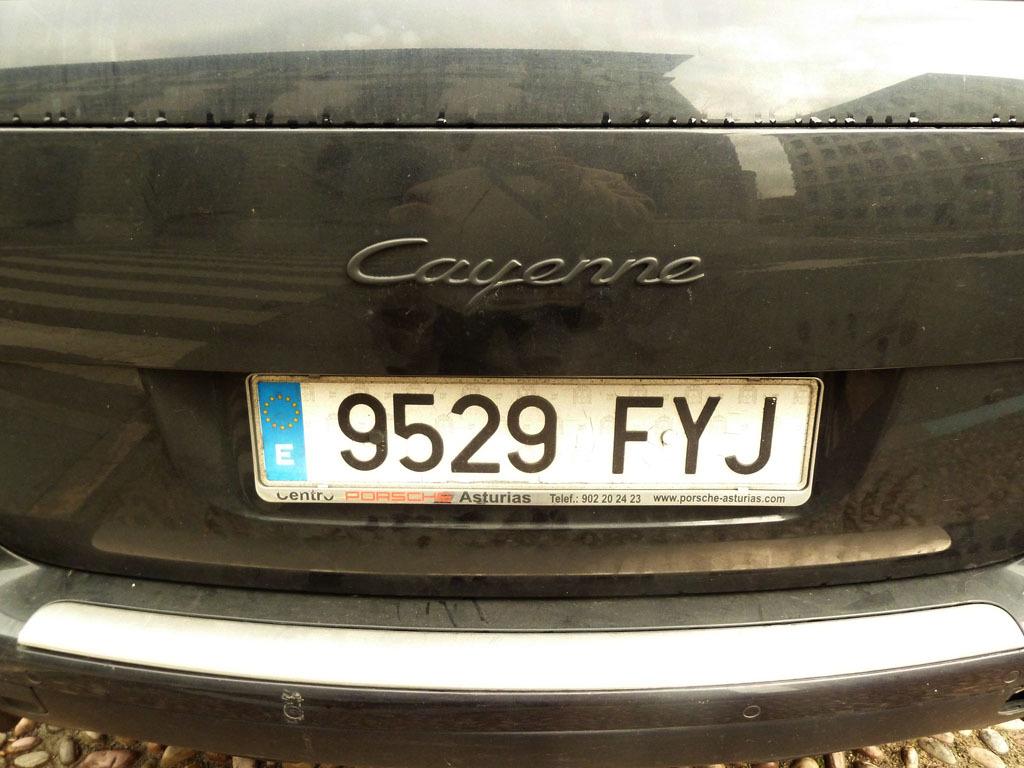What is the license plate number of the car?
Your response must be concise. 9529 fyj. 